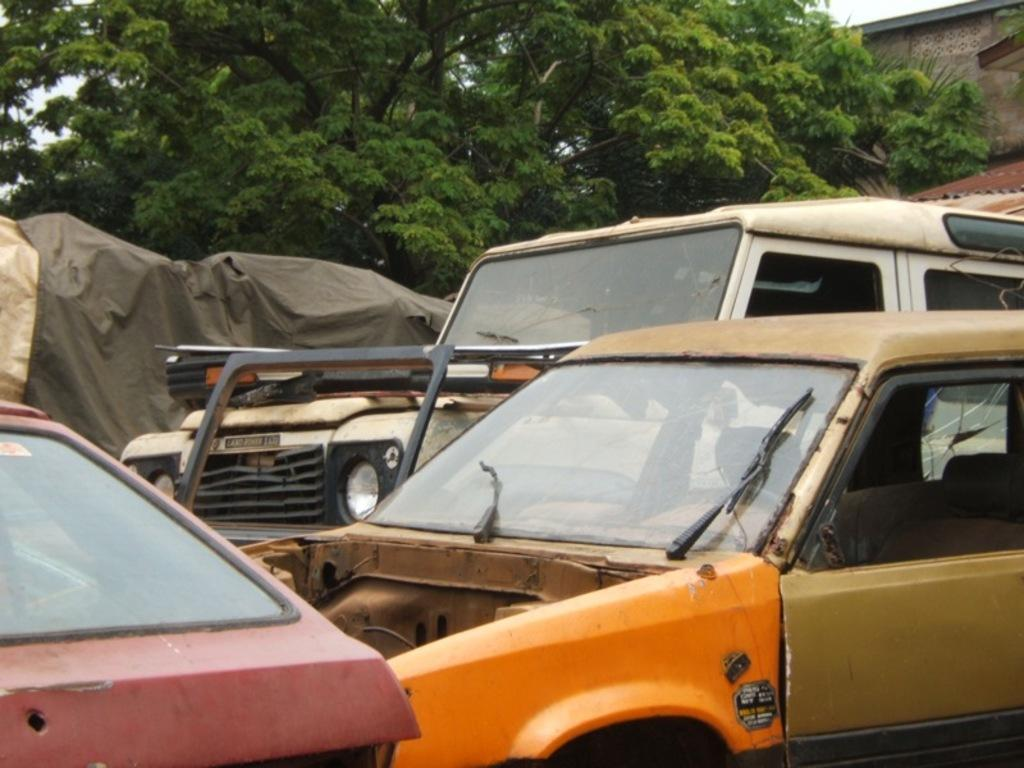What types of objects can be seen in the image? There are vehicles in the image. What material is visible in the image? There is cloth visible in the image. What type of natural elements can be seen in the image? There are trees in the image. Where are the objects located in the image? There are objects in the top right corner of the image. What type of grass can be seen growing in the image? There is no grass visible in the image; it features vehicles, cloth, trees, and objects in the top right corner. 